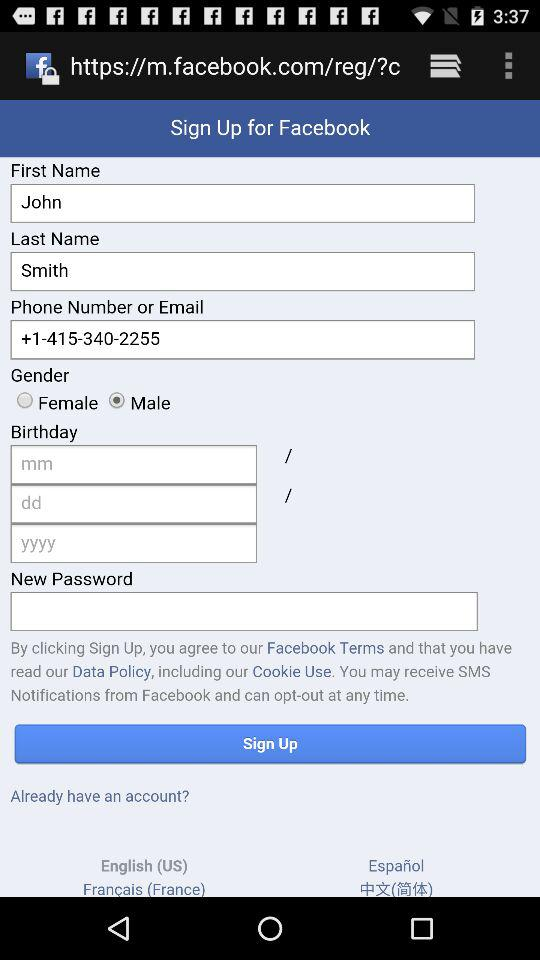What is the phone number? The phone number is +1-415-340-2255. 